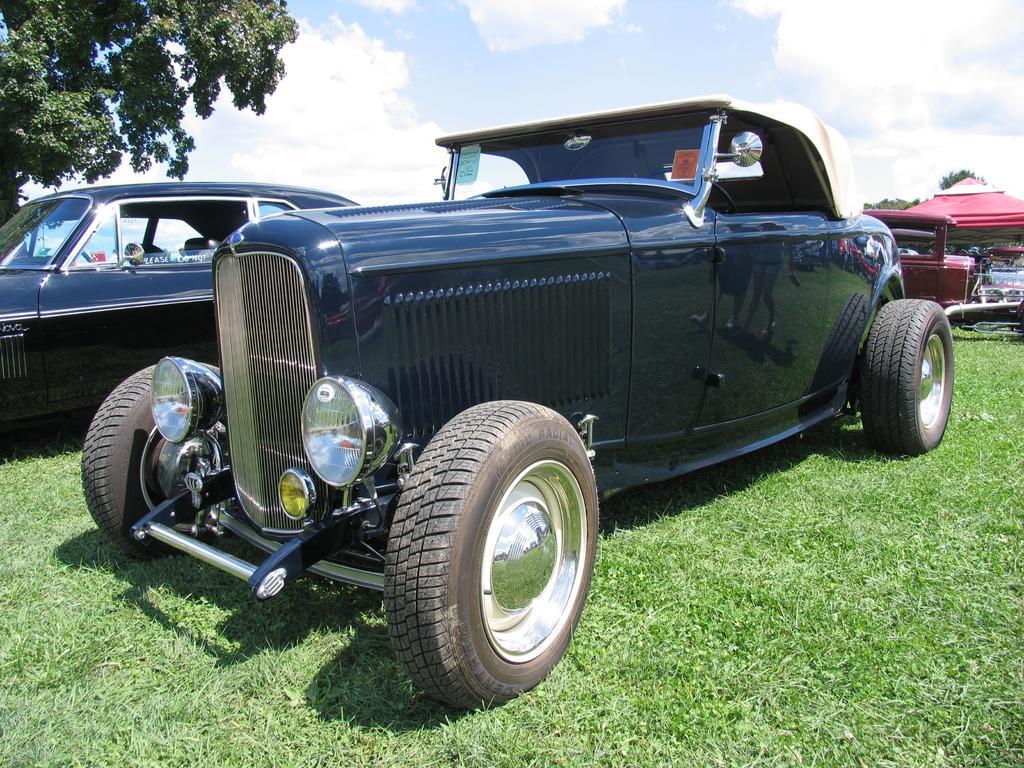How would you summarize this image in a sentence or two? In this picture I can see vehicles on the green grass. I can see the tree on the left side. I can see clouds in the sky. 